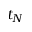Convert formula to latex. <formula><loc_0><loc_0><loc_500><loc_500>t _ { N }</formula> 